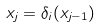<formula> <loc_0><loc_0><loc_500><loc_500>x _ { j } = \delta _ { i } ( x _ { j - 1 } )</formula> 